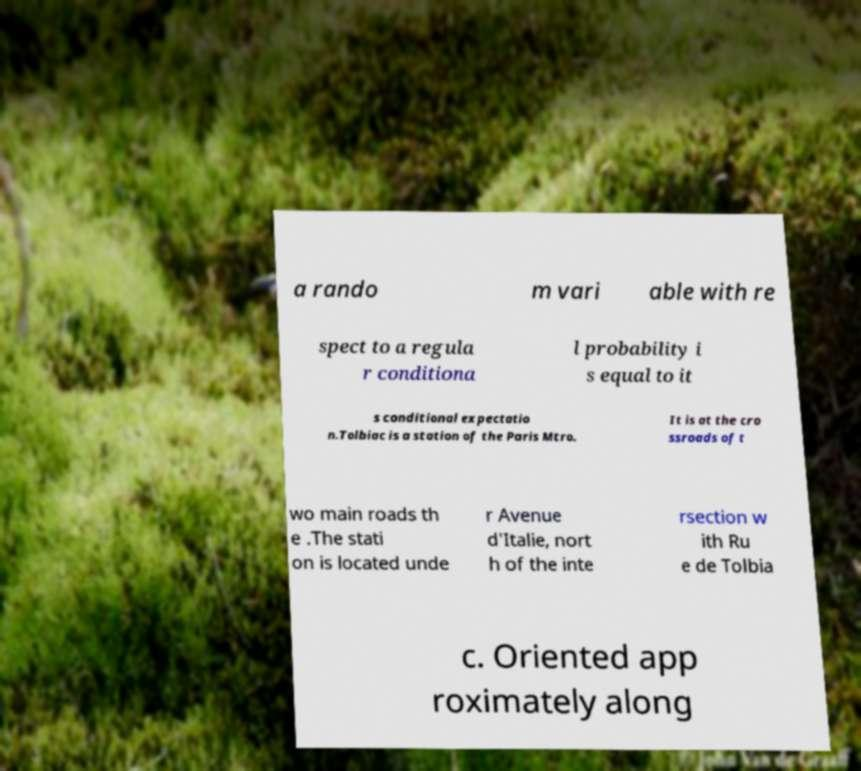For documentation purposes, I need the text within this image transcribed. Could you provide that? a rando m vari able with re spect to a regula r conditiona l probability i s equal to it s conditional expectatio n.Tolbiac is a station of the Paris Mtro. It is at the cro ssroads of t wo main roads th e .The stati on is located unde r Avenue d'Italie, nort h of the inte rsection w ith Ru e de Tolbia c. Oriented app roximately along 